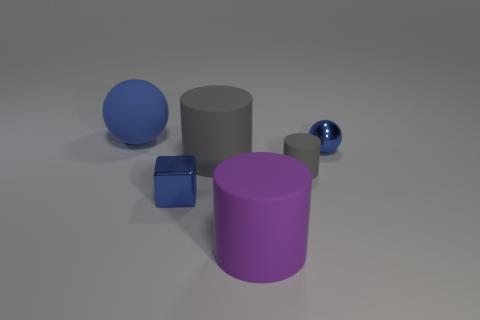Add 1 large cyan metallic spheres. How many objects exist? 7 Subtract all spheres. How many objects are left? 4 Subtract all metal spheres. Subtract all large purple matte objects. How many objects are left? 4 Add 5 purple cylinders. How many purple cylinders are left? 6 Add 1 large objects. How many large objects exist? 4 Subtract 1 blue spheres. How many objects are left? 5 